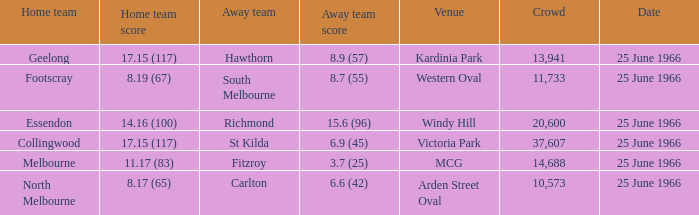When a home team registered 1 St Kilda. 